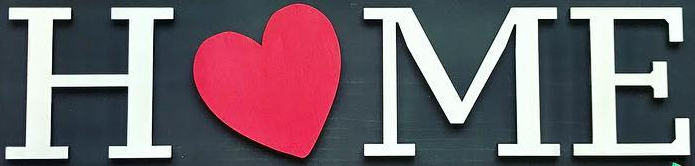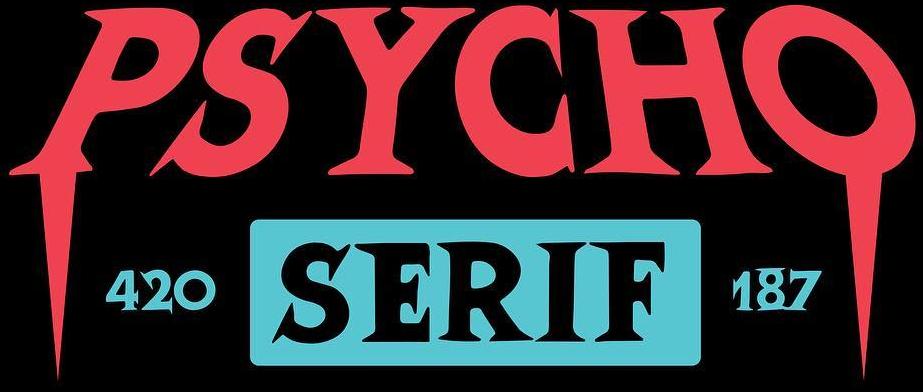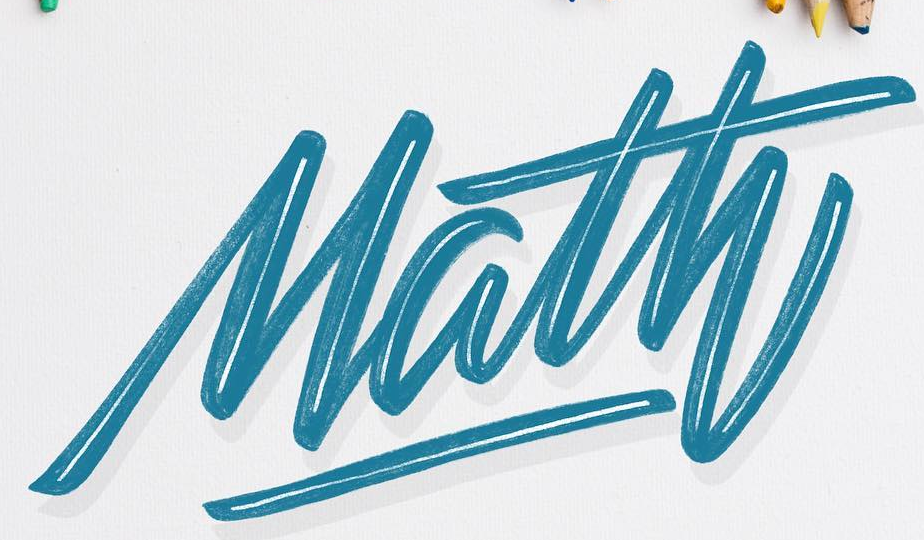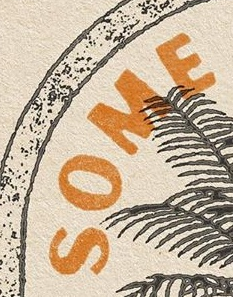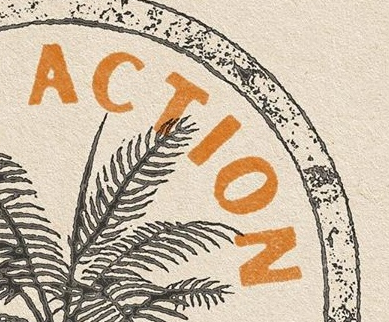What words can you see in these images in sequence, separated by a semicolon? HOME; PSYCHO; Math; SOME; ACTION 